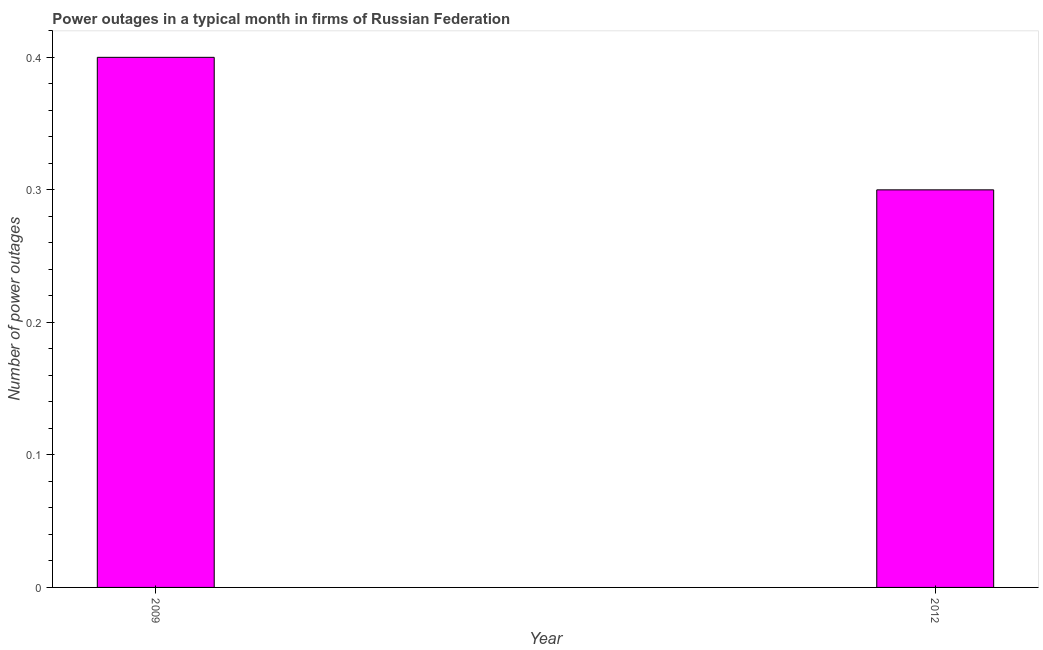Does the graph contain any zero values?
Give a very brief answer. No. What is the title of the graph?
Offer a terse response. Power outages in a typical month in firms of Russian Federation. What is the label or title of the Y-axis?
Make the answer very short. Number of power outages. What is the number of power outages in 2009?
Your answer should be compact. 0.4. Across all years, what is the minimum number of power outages?
Your answer should be very brief. 0.3. What is the sum of the number of power outages?
Offer a terse response. 0.7. What is the difference between the number of power outages in 2009 and 2012?
Ensure brevity in your answer.  0.1. What is the average number of power outages per year?
Offer a terse response. 0.35. What is the median number of power outages?
Ensure brevity in your answer.  0.35. In how many years, is the number of power outages greater than 0.36 ?
Provide a succinct answer. 1. Do a majority of the years between 2009 and 2012 (inclusive) have number of power outages greater than 0.06 ?
Keep it short and to the point. Yes. What is the ratio of the number of power outages in 2009 to that in 2012?
Make the answer very short. 1.33. Is the number of power outages in 2009 less than that in 2012?
Provide a succinct answer. No. In how many years, is the number of power outages greater than the average number of power outages taken over all years?
Keep it short and to the point. 1. What is the Number of power outages in 2009?
Your answer should be compact. 0.4. What is the difference between the Number of power outages in 2009 and 2012?
Give a very brief answer. 0.1. What is the ratio of the Number of power outages in 2009 to that in 2012?
Make the answer very short. 1.33. 